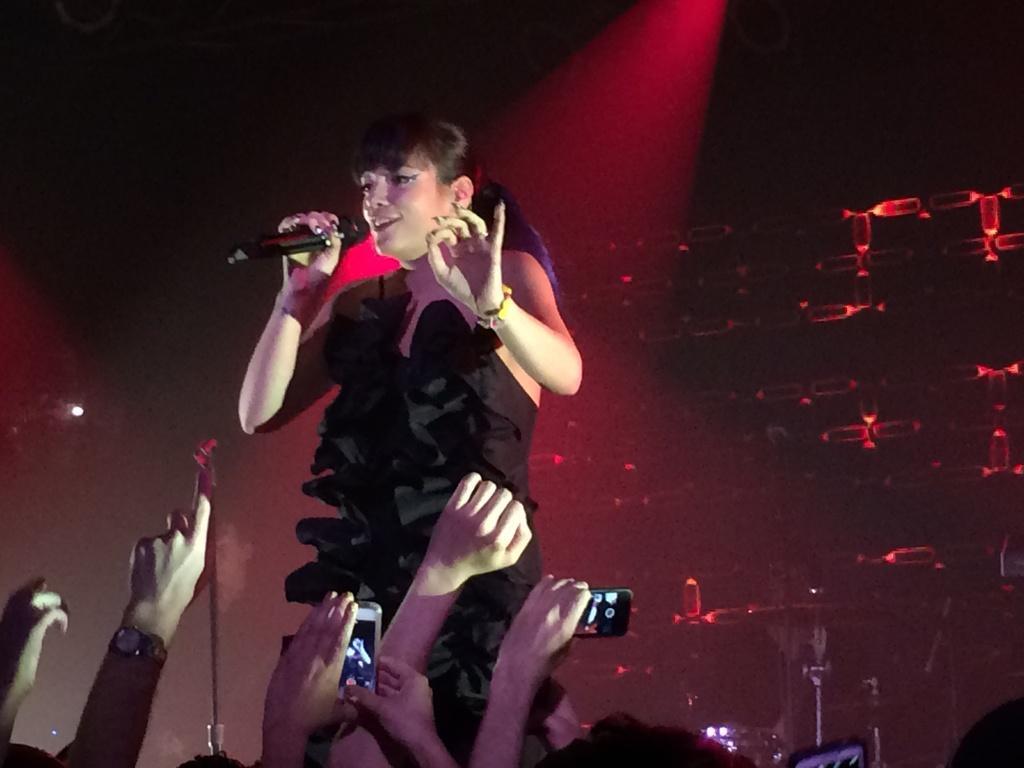Could you give a brief overview of what you see in this image? In this image we can see a woman is standing and smiling, and holding a micro phone in the hand ,and here a group of persons are standing. 